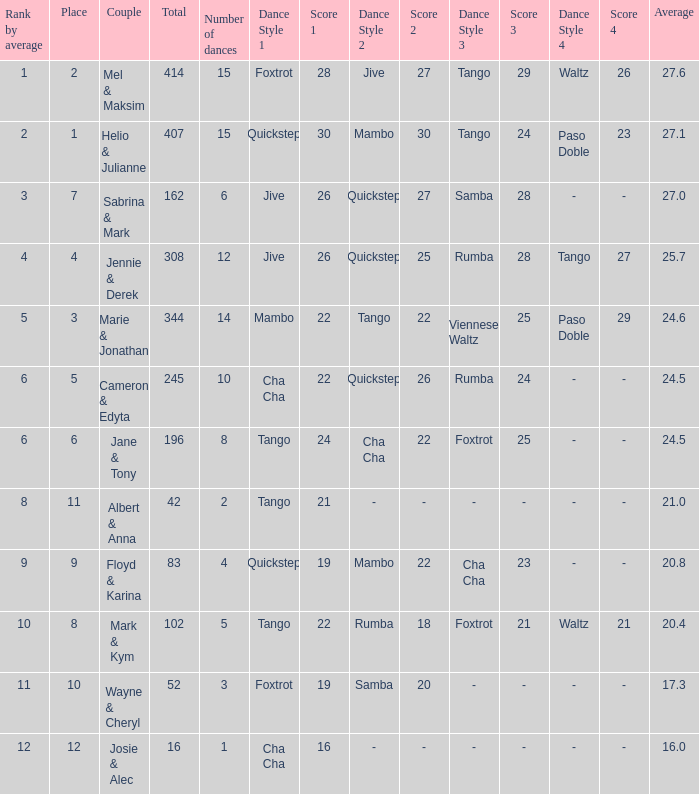What is the average place for a couple with the rank by average of 9 and total smaller than 83? None. 